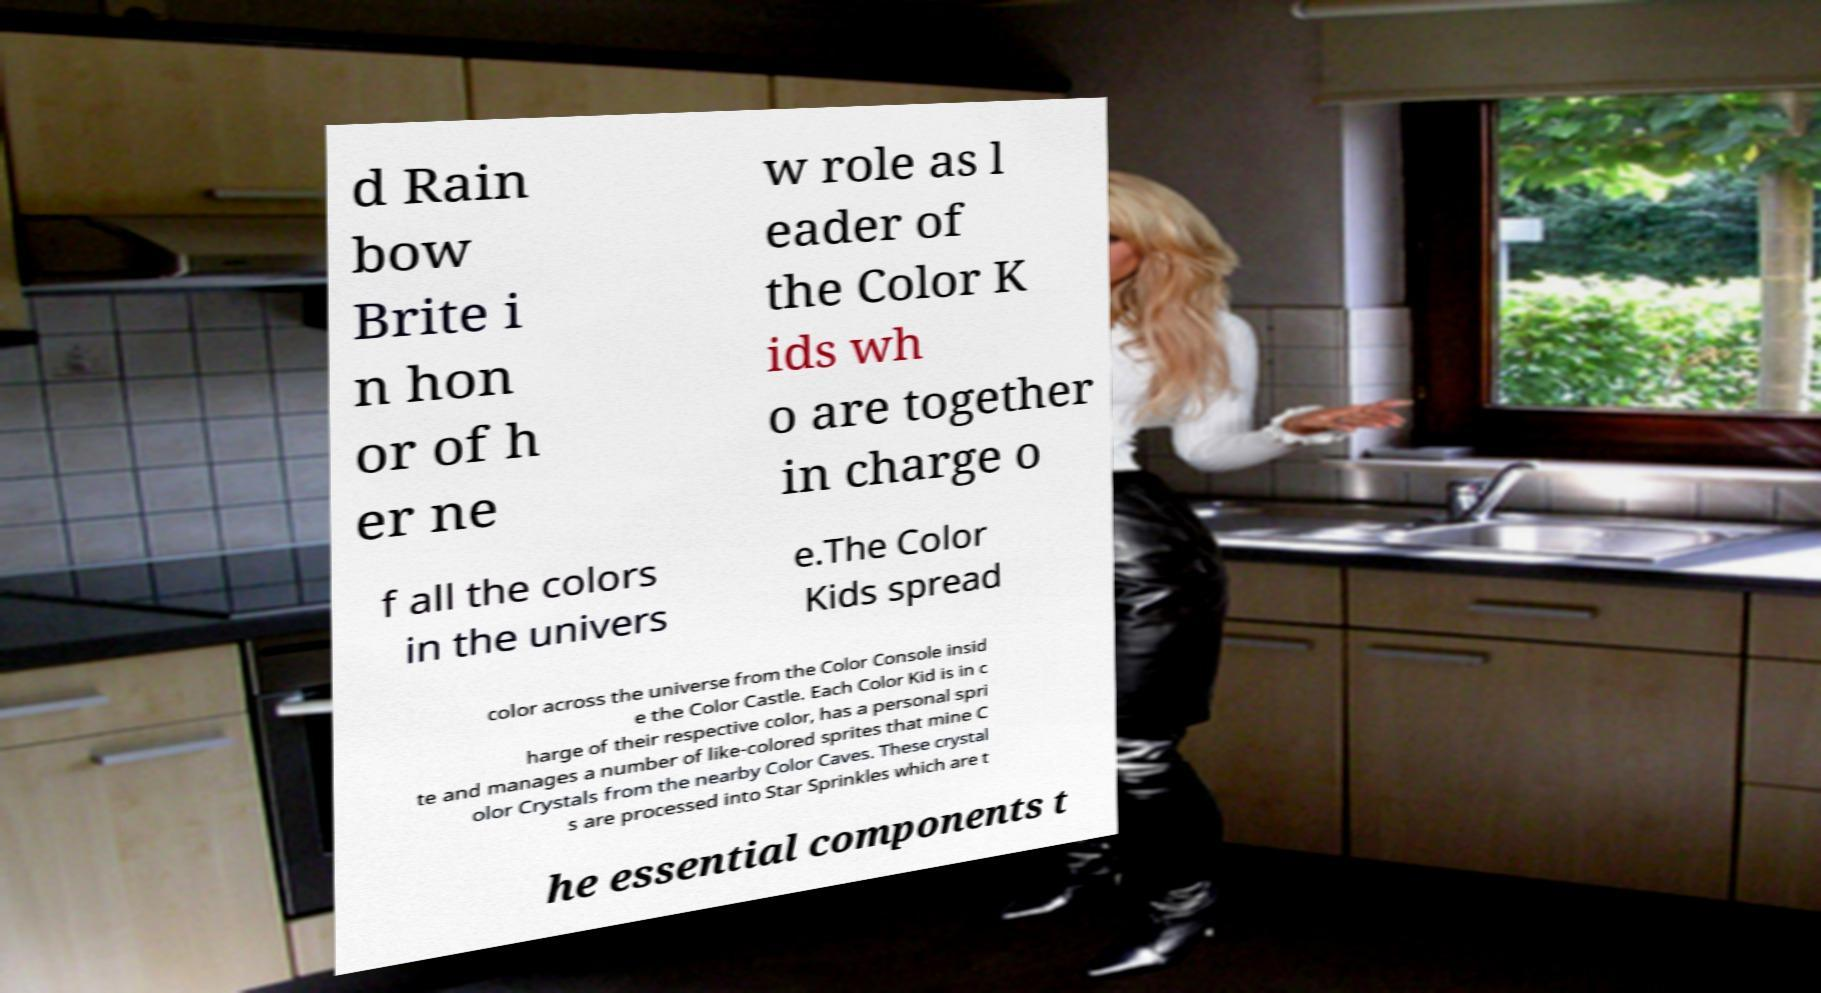Could you extract and type out the text from this image? d Rain bow Brite i n hon or of h er ne w role as l eader of the Color K ids wh o are together in charge o f all the colors in the univers e.The Color Kids spread color across the universe from the Color Console insid e the Color Castle. Each Color Kid is in c harge of their respective color, has a personal spri te and manages a number of like-colored sprites that mine C olor Crystals from the nearby Color Caves. These crystal s are processed into Star Sprinkles which are t he essential components t 